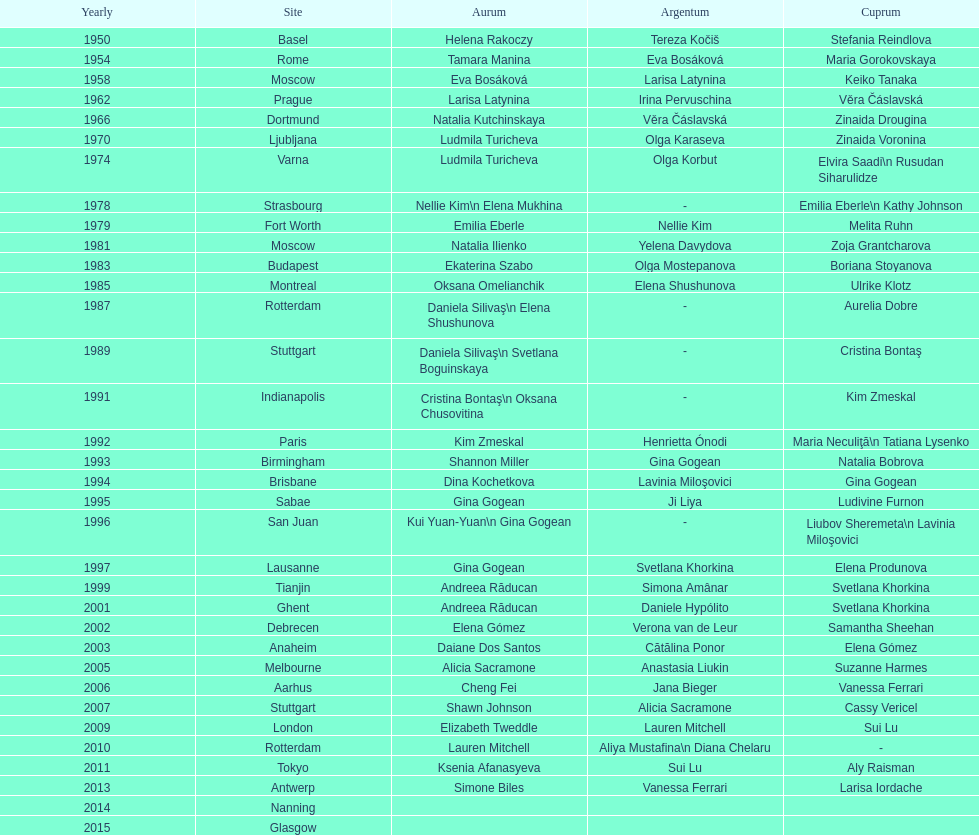How many times was the location in the united states? 3. 